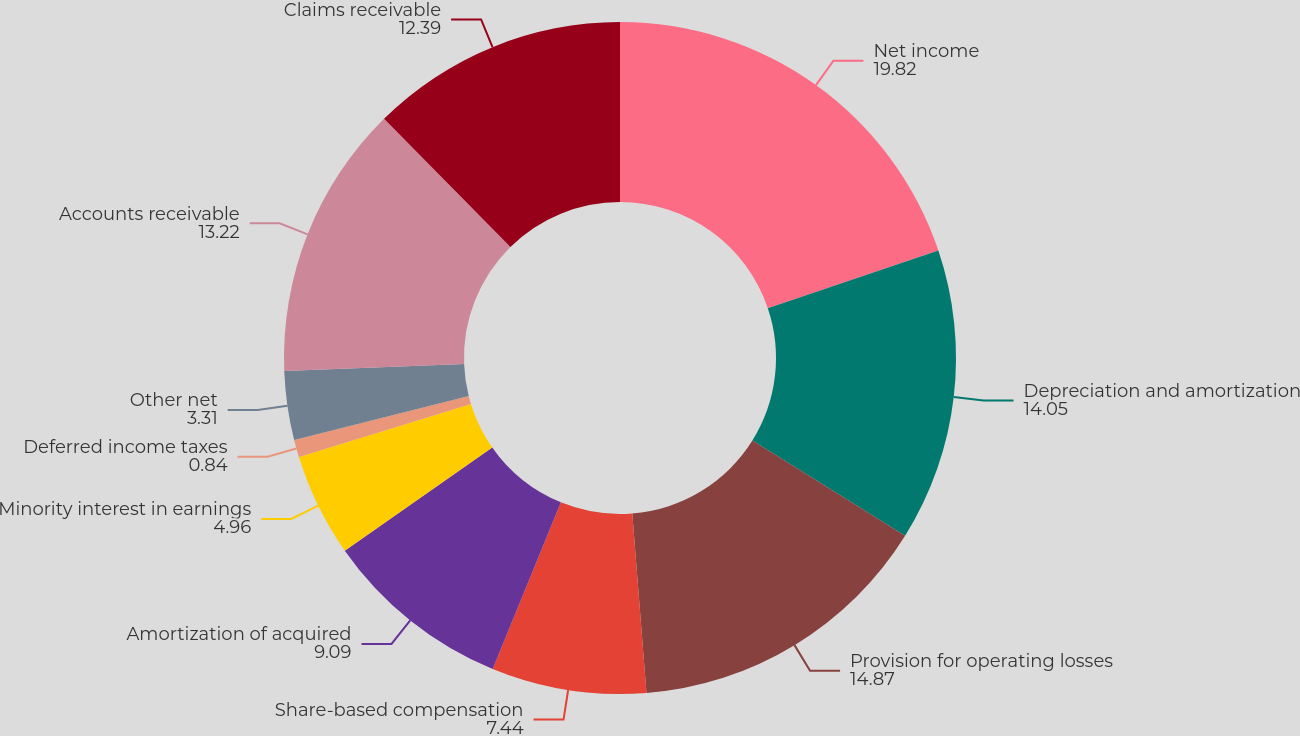<chart> <loc_0><loc_0><loc_500><loc_500><pie_chart><fcel>Net income<fcel>Depreciation and amortization<fcel>Provision for operating losses<fcel>Share-based compensation<fcel>Amortization of acquired<fcel>Minority interest in earnings<fcel>Deferred income taxes<fcel>Other net<fcel>Accounts receivable<fcel>Claims receivable<nl><fcel>19.82%<fcel>14.05%<fcel>14.87%<fcel>7.44%<fcel>9.09%<fcel>4.96%<fcel>0.84%<fcel>3.31%<fcel>13.22%<fcel>12.39%<nl></chart> 